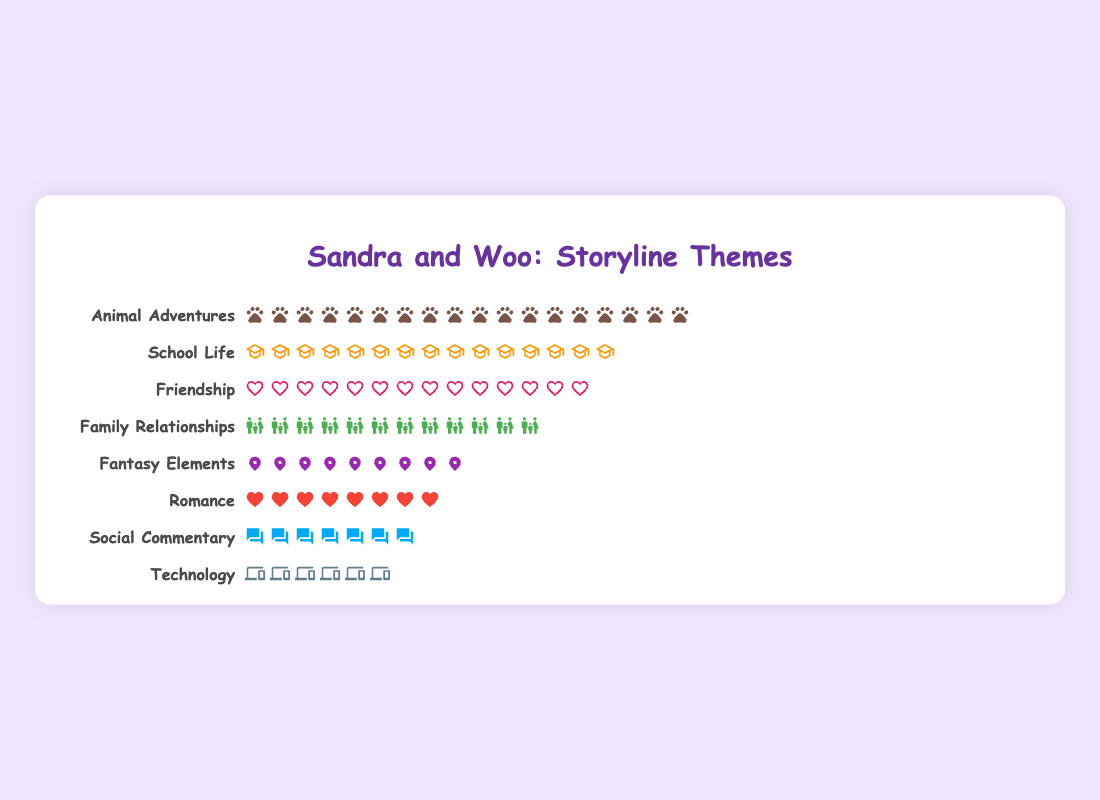What's the total number of storyline themes represented in the figure? Count the number of different themes listed. There are 8 rows, each with a different theme.
Answer: 8 Which theme has the highest count of occurrences? Observe the number of icons in each theme row. "Animal Adventures" has 18 icons, which is more than any other.
Answer: Animal Adventures How many more occurrences does "Animal Adventures" have compared to "Technology"? Count the icons in both themes: "Animal Adventures" has 18 icons, and "Technology" has 6. The difference is 18 - 6.
Answer: 12 What's the total count of occurrences for "School Life" and "Friendship" combined? Count the icons in "School Life" (15) and "Friendship" (14) and sum them. 15 + 14 = 29.
Answer: 29 Which theme appears least frequently, and how many times does it appear? Identify the row with the fewest icons. "Technology" has 6 icons, making it the least frequent.
Answer: Technology, 6 How many themes have more than 10 occurrences? Count the themes with more than 10 icons. "Animal Adventures" (18), "School Life" (15), "Friendship" (14), and "Family Relationships" (12) all have more than 10.
Answer: 4 What’s the difference in counts between "Family Relationships" and "Fantasy Elements"? Count the icons: "Family Relationships" has 12 and "Fantasy Elements" has 9. Subtract 9 from 12: 12 - 9.
Answer: 3 How many more themes are there with fewer than 10 occurrences compared to those with more than 10? Count themes with fewer than 10 ("Fantasy Elements" - 9, "Social Commentary" - 7, "Technology" - 6, "Romance" - 8): 4. Count themes with more than 10 ("Animal Adventures" - 18, "School Life" - 15, "Friendship" - 14, "Family Relationships" - 12): 4. The difference is 4 - 4.
Answer: 0 Which two themes have counts that are closest to each other? Compare the counts of all themes: "Fantasy Elements" (9) and "Romance" (8) are closest with a difference of 1.
Answer: Fantasy Elements and Romance What percentage of the total themes does "Social Commentary" represent? Calculate the total number of occurrences: 15 + 12 + 18 + 9 + 14 + 7 + 6 + 8 = 89. "Social Commentary" has 7. The percentage is (7/89) * 100.
Answer: ~7.87% 